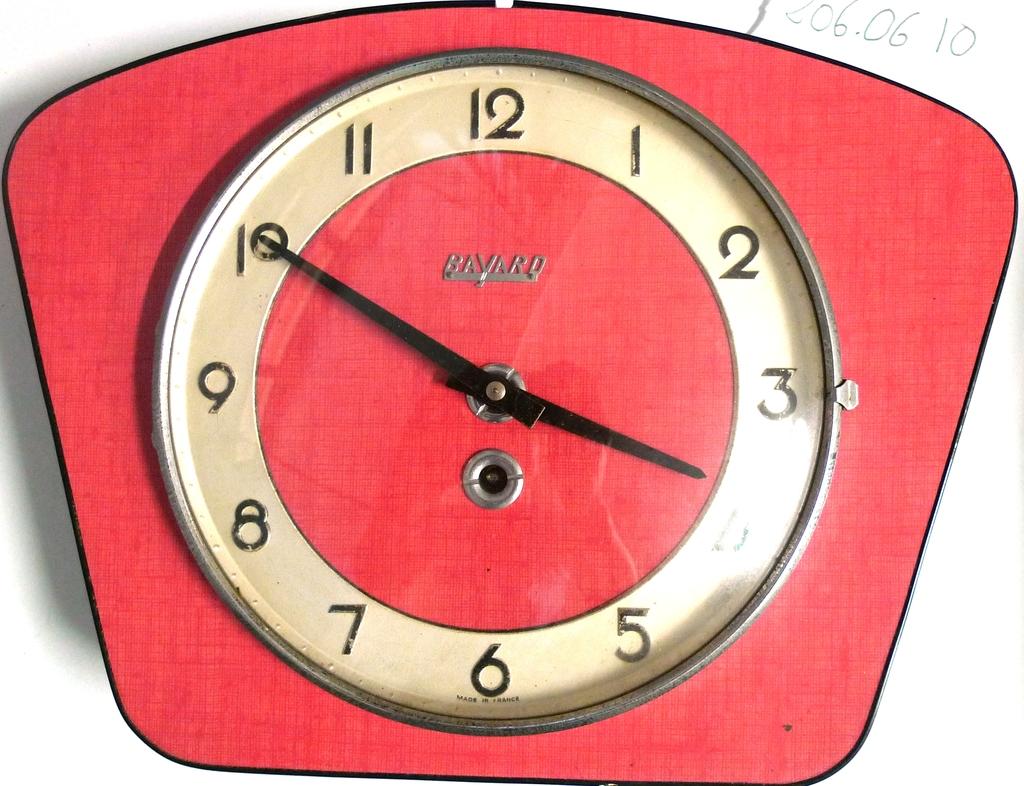What time is it?
Offer a very short reply. 3:50. 